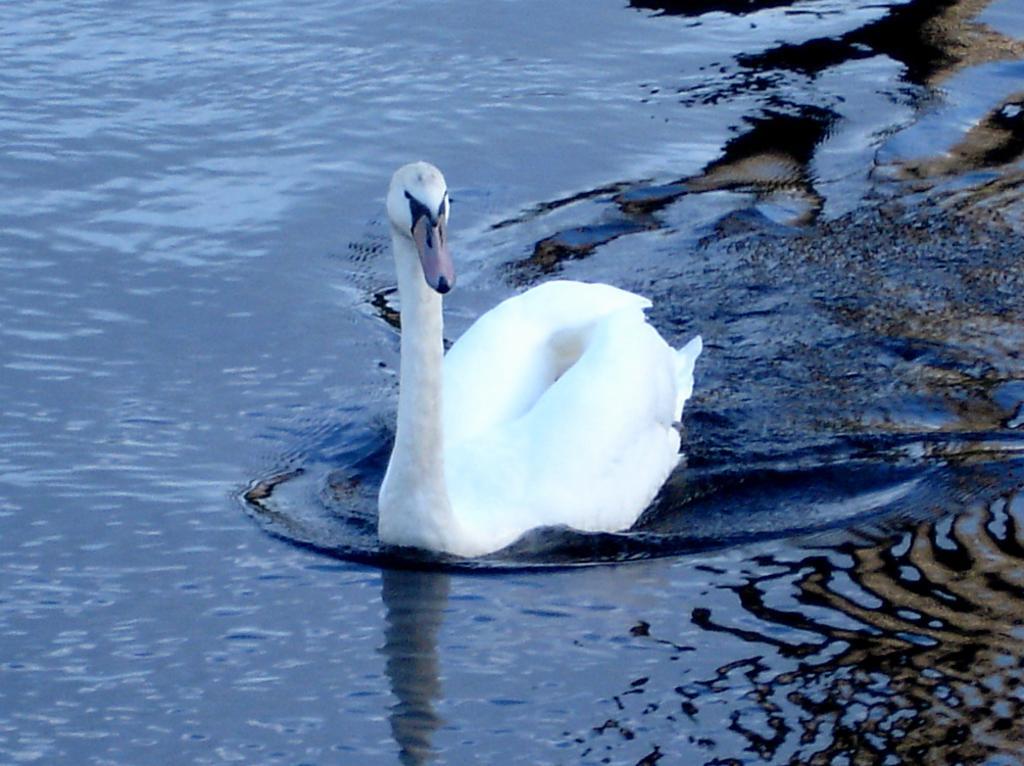Can you describe this image briefly? In this image we can see there is a duck on the water. 